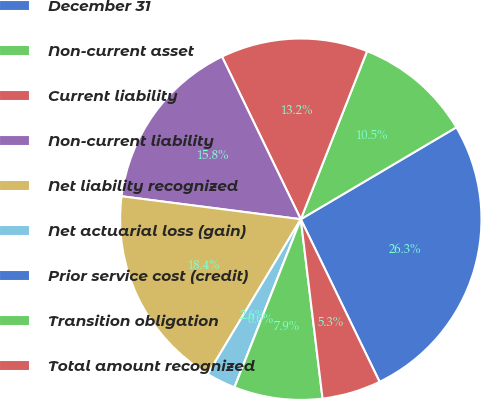<chart> <loc_0><loc_0><loc_500><loc_500><pie_chart><fcel>December 31<fcel>Non-current asset<fcel>Current liability<fcel>Non-current liability<fcel>Net liability recognized<fcel>Net actuarial loss (gain)<fcel>Prior service cost (credit)<fcel>Transition obligation<fcel>Total amount recognized<nl><fcel>26.31%<fcel>10.53%<fcel>13.16%<fcel>15.79%<fcel>18.42%<fcel>2.63%<fcel>0.0%<fcel>7.9%<fcel>5.26%<nl></chart> 